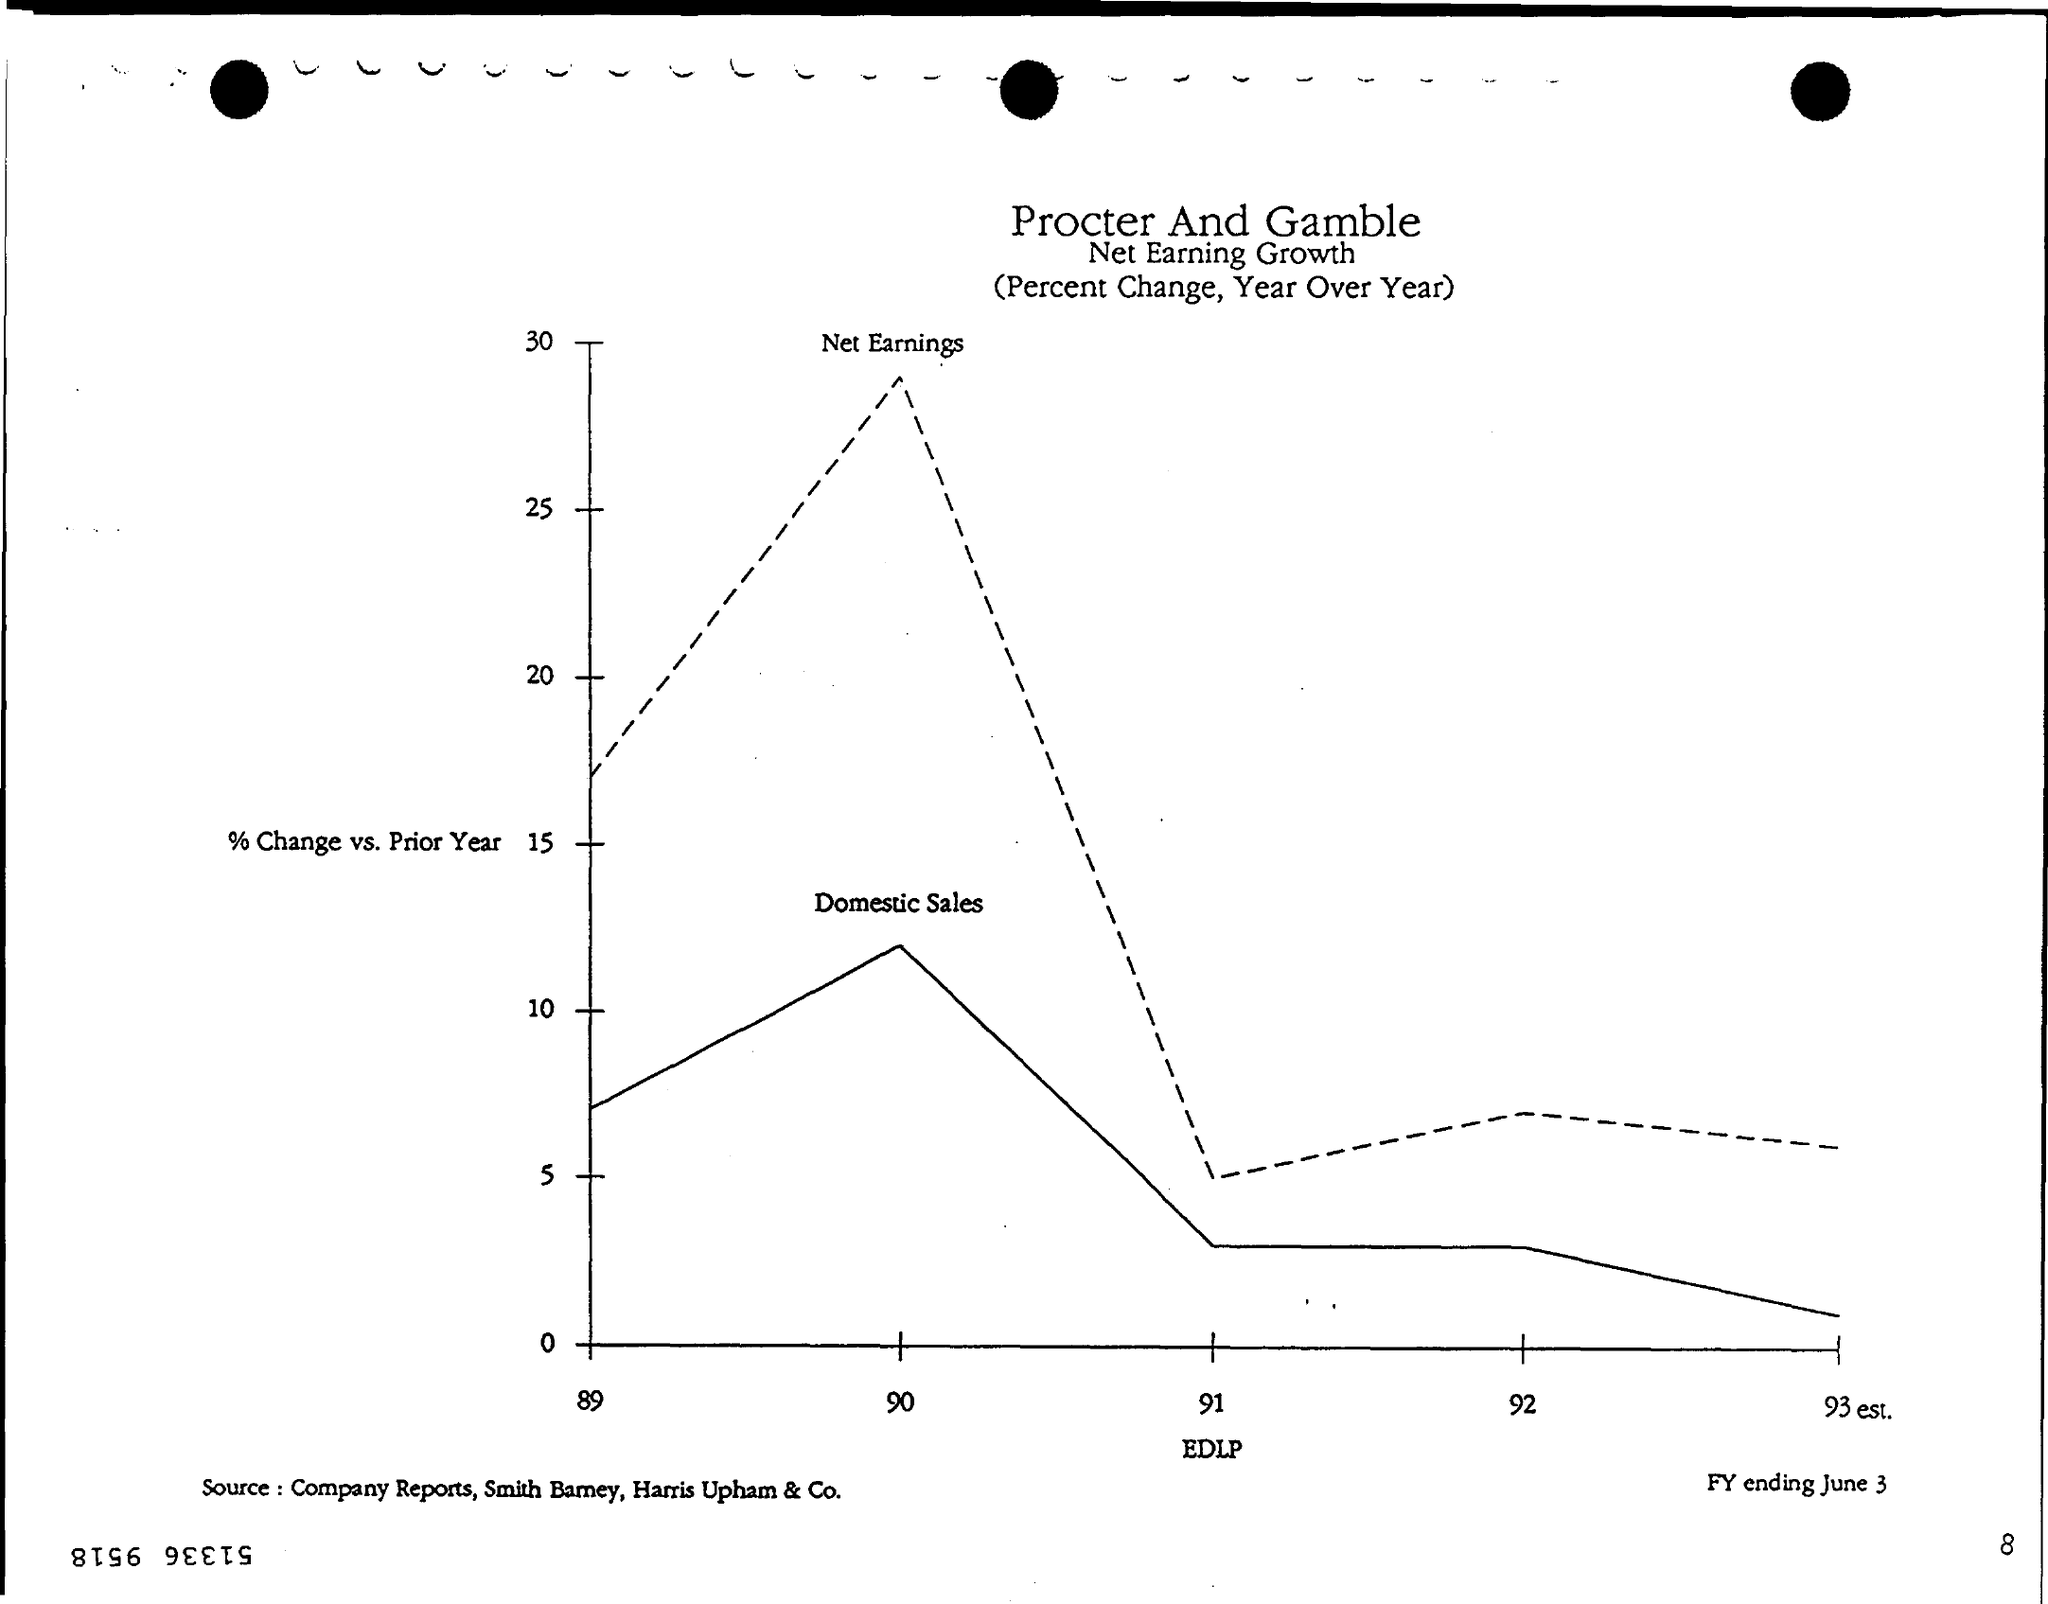What is plotted on the x-axis?
Your response must be concise. EDLP. What is plotted on the y-axis?
Keep it short and to the point. % Change vs. Prior Year. What is the Page Number?
Provide a succinct answer. 8. What is the first title in the document?
Your answer should be very brief. Procter and Gamble. 